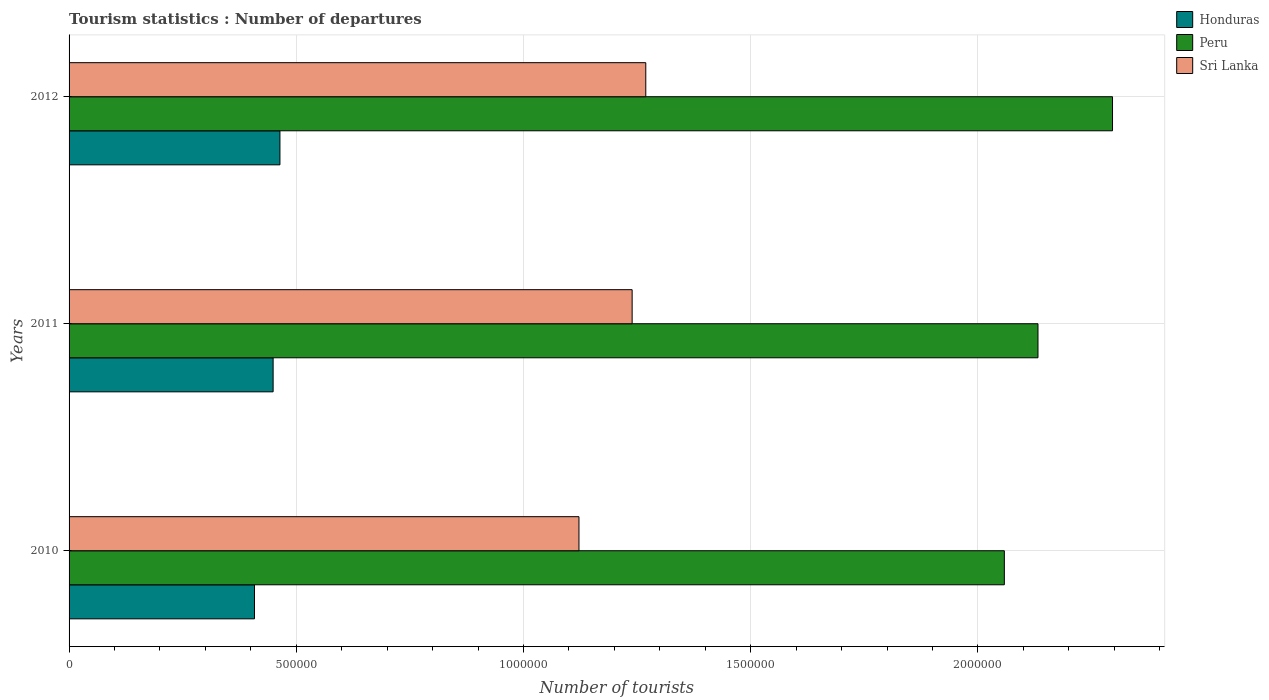Are the number of bars per tick equal to the number of legend labels?
Provide a succinct answer. Yes. How many bars are there on the 1st tick from the top?
Offer a terse response. 3. What is the label of the 1st group of bars from the top?
Give a very brief answer. 2012. What is the number of tourist departures in Sri Lanka in 2012?
Offer a very short reply. 1.27e+06. Across all years, what is the maximum number of tourist departures in Sri Lanka?
Offer a terse response. 1.27e+06. Across all years, what is the minimum number of tourist departures in Honduras?
Offer a very short reply. 4.08e+05. In which year was the number of tourist departures in Honduras maximum?
Keep it short and to the point. 2012. What is the total number of tourist departures in Honduras in the graph?
Offer a very short reply. 1.32e+06. What is the difference between the number of tourist departures in Sri Lanka in 2010 and that in 2012?
Provide a short and direct response. -1.47e+05. What is the difference between the number of tourist departures in Honduras in 2010 and the number of tourist departures in Sri Lanka in 2012?
Provide a succinct answer. -8.61e+05. What is the average number of tourist departures in Peru per year?
Offer a terse response. 2.16e+06. In the year 2011, what is the difference between the number of tourist departures in Peru and number of tourist departures in Honduras?
Keep it short and to the point. 1.68e+06. What is the ratio of the number of tourist departures in Honduras in 2010 to that in 2012?
Your response must be concise. 0.88. What is the difference between the highest and the lowest number of tourist departures in Peru?
Your answer should be very brief. 2.38e+05. Is the sum of the number of tourist departures in Honduras in 2011 and 2012 greater than the maximum number of tourist departures in Peru across all years?
Ensure brevity in your answer.  No. What does the 3rd bar from the top in 2011 represents?
Offer a very short reply. Honduras. Is it the case that in every year, the sum of the number of tourist departures in Honduras and number of tourist departures in Sri Lanka is greater than the number of tourist departures in Peru?
Ensure brevity in your answer.  No. How many bars are there?
Give a very brief answer. 9. What is the difference between two consecutive major ticks on the X-axis?
Ensure brevity in your answer.  5.00e+05. Are the values on the major ticks of X-axis written in scientific E-notation?
Your answer should be compact. No. How are the legend labels stacked?
Provide a short and direct response. Vertical. What is the title of the graph?
Offer a terse response. Tourism statistics : Number of departures. What is the label or title of the X-axis?
Your answer should be very brief. Number of tourists. What is the Number of tourists of Honduras in 2010?
Ensure brevity in your answer.  4.08e+05. What is the Number of tourists of Peru in 2010?
Ensure brevity in your answer.  2.06e+06. What is the Number of tourists in Sri Lanka in 2010?
Provide a short and direct response. 1.12e+06. What is the Number of tourists of Honduras in 2011?
Give a very brief answer. 4.49e+05. What is the Number of tourists of Peru in 2011?
Ensure brevity in your answer.  2.13e+06. What is the Number of tourists of Sri Lanka in 2011?
Give a very brief answer. 1.24e+06. What is the Number of tourists in Honduras in 2012?
Make the answer very short. 4.64e+05. What is the Number of tourists of Peru in 2012?
Provide a succinct answer. 2.30e+06. What is the Number of tourists in Sri Lanka in 2012?
Provide a short and direct response. 1.27e+06. Across all years, what is the maximum Number of tourists of Honduras?
Offer a terse response. 4.64e+05. Across all years, what is the maximum Number of tourists of Peru?
Offer a terse response. 2.30e+06. Across all years, what is the maximum Number of tourists of Sri Lanka?
Your answer should be very brief. 1.27e+06. Across all years, what is the minimum Number of tourists in Honduras?
Give a very brief answer. 4.08e+05. Across all years, what is the minimum Number of tourists in Peru?
Offer a very short reply. 2.06e+06. Across all years, what is the minimum Number of tourists of Sri Lanka?
Provide a succinct answer. 1.12e+06. What is the total Number of tourists of Honduras in the graph?
Your response must be concise. 1.32e+06. What is the total Number of tourists in Peru in the graph?
Your answer should be very brief. 6.49e+06. What is the total Number of tourists of Sri Lanka in the graph?
Your response must be concise. 3.63e+06. What is the difference between the Number of tourists in Honduras in 2010 and that in 2011?
Your response must be concise. -4.10e+04. What is the difference between the Number of tourists of Peru in 2010 and that in 2011?
Provide a short and direct response. -7.40e+04. What is the difference between the Number of tourists in Sri Lanka in 2010 and that in 2011?
Provide a succinct answer. -1.17e+05. What is the difference between the Number of tourists in Honduras in 2010 and that in 2012?
Give a very brief answer. -5.60e+04. What is the difference between the Number of tourists in Peru in 2010 and that in 2012?
Your answer should be very brief. -2.38e+05. What is the difference between the Number of tourists of Sri Lanka in 2010 and that in 2012?
Provide a succinct answer. -1.47e+05. What is the difference between the Number of tourists of Honduras in 2011 and that in 2012?
Provide a short and direct response. -1.50e+04. What is the difference between the Number of tourists of Peru in 2011 and that in 2012?
Offer a terse response. -1.64e+05. What is the difference between the Number of tourists of Sri Lanka in 2011 and that in 2012?
Make the answer very short. -3.00e+04. What is the difference between the Number of tourists of Honduras in 2010 and the Number of tourists of Peru in 2011?
Make the answer very short. -1.72e+06. What is the difference between the Number of tourists in Honduras in 2010 and the Number of tourists in Sri Lanka in 2011?
Ensure brevity in your answer.  -8.31e+05. What is the difference between the Number of tourists in Peru in 2010 and the Number of tourists in Sri Lanka in 2011?
Offer a very short reply. 8.19e+05. What is the difference between the Number of tourists of Honduras in 2010 and the Number of tourists of Peru in 2012?
Provide a succinct answer. -1.89e+06. What is the difference between the Number of tourists in Honduras in 2010 and the Number of tourists in Sri Lanka in 2012?
Ensure brevity in your answer.  -8.61e+05. What is the difference between the Number of tourists of Peru in 2010 and the Number of tourists of Sri Lanka in 2012?
Offer a terse response. 7.89e+05. What is the difference between the Number of tourists in Honduras in 2011 and the Number of tourists in Peru in 2012?
Your answer should be very brief. -1.85e+06. What is the difference between the Number of tourists of Honduras in 2011 and the Number of tourists of Sri Lanka in 2012?
Ensure brevity in your answer.  -8.20e+05. What is the difference between the Number of tourists of Peru in 2011 and the Number of tourists of Sri Lanka in 2012?
Make the answer very short. 8.63e+05. What is the average Number of tourists in Honduras per year?
Keep it short and to the point. 4.40e+05. What is the average Number of tourists in Peru per year?
Provide a short and direct response. 2.16e+06. What is the average Number of tourists in Sri Lanka per year?
Make the answer very short. 1.21e+06. In the year 2010, what is the difference between the Number of tourists of Honduras and Number of tourists of Peru?
Your response must be concise. -1.65e+06. In the year 2010, what is the difference between the Number of tourists in Honduras and Number of tourists in Sri Lanka?
Your response must be concise. -7.14e+05. In the year 2010, what is the difference between the Number of tourists in Peru and Number of tourists in Sri Lanka?
Keep it short and to the point. 9.36e+05. In the year 2011, what is the difference between the Number of tourists in Honduras and Number of tourists in Peru?
Give a very brief answer. -1.68e+06. In the year 2011, what is the difference between the Number of tourists in Honduras and Number of tourists in Sri Lanka?
Provide a short and direct response. -7.90e+05. In the year 2011, what is the difference between the Number of tourists of Peru and Number of tourists of Sri Lanka?
Your response must be concise. 8.93e+05. In the year 2012, what is the difference between the Number of tourists in Honduras and Number of tourists in Peru?
Ensure brevity in your answer.  -1.83e+06. In the year 2012, what is the difference between the Number of tourists of Honduras and Number of tourists of Sri Lanka?
Make the answer very short. -8.05e+05. In the year 2012, what is the difference between the Number of tourists in Peru and Number of tourists in Sri Lanka?
Your response must be concise. 1.03e+06. What is the ratio of the Number of tourists of Honduras in 2010 to that in 2011?
Keep it short and to the point. 0.91. What is the ratio of the Number of tourists of Peru in 2010 to that in 2011?
Your answer should be very brief. 0.97. What is the ratio of the Number of tourists of Sri Lanka in 2010 to that in 2011?
Your answer should be very brief. 0.91. What is the ratio of the Number of tourists in Honduras in 2010 to that in 2012?
Offer a very short reply. 0.88. What is the ratio of the Number of tourists of Peru in 2010 to that in 2012?
Make the answer very short. 0.9. What is the ratio of the Number of tourists of Sri Lanka in 2010 to that in 2012?
Ensure brevity in your answer.  0.88. What is the ratio of the Number of tourists in Honduras in 2011 to that in 2012?
Your answer should be compact. 0.97. What is the ratio of the Number of tourists in Sri Lanka in 2011 to that in 2012?
Keep it short and to the point. 0.98. What is the difference between the highest and the second highest Number of tourists of Honduras?
Your answer should be very brief. 1.50e+04. What is the difference between the highest and the second highest Number of tourists of Peru?
Offer a terse response. 1.64e+05. What is the difference between the highest and the lowest Number of tourists in Honduras?
Provide a succinct answer. 5.60e+04. What is the difference between the highest and the lowest Number of tourists of Peru?
Offer a very short reply. 2.38e+05. What is the difference between the highest and the lowest Number of tourists of Sri Lanka?
Provide a succinct answer. 1.47e+05. 